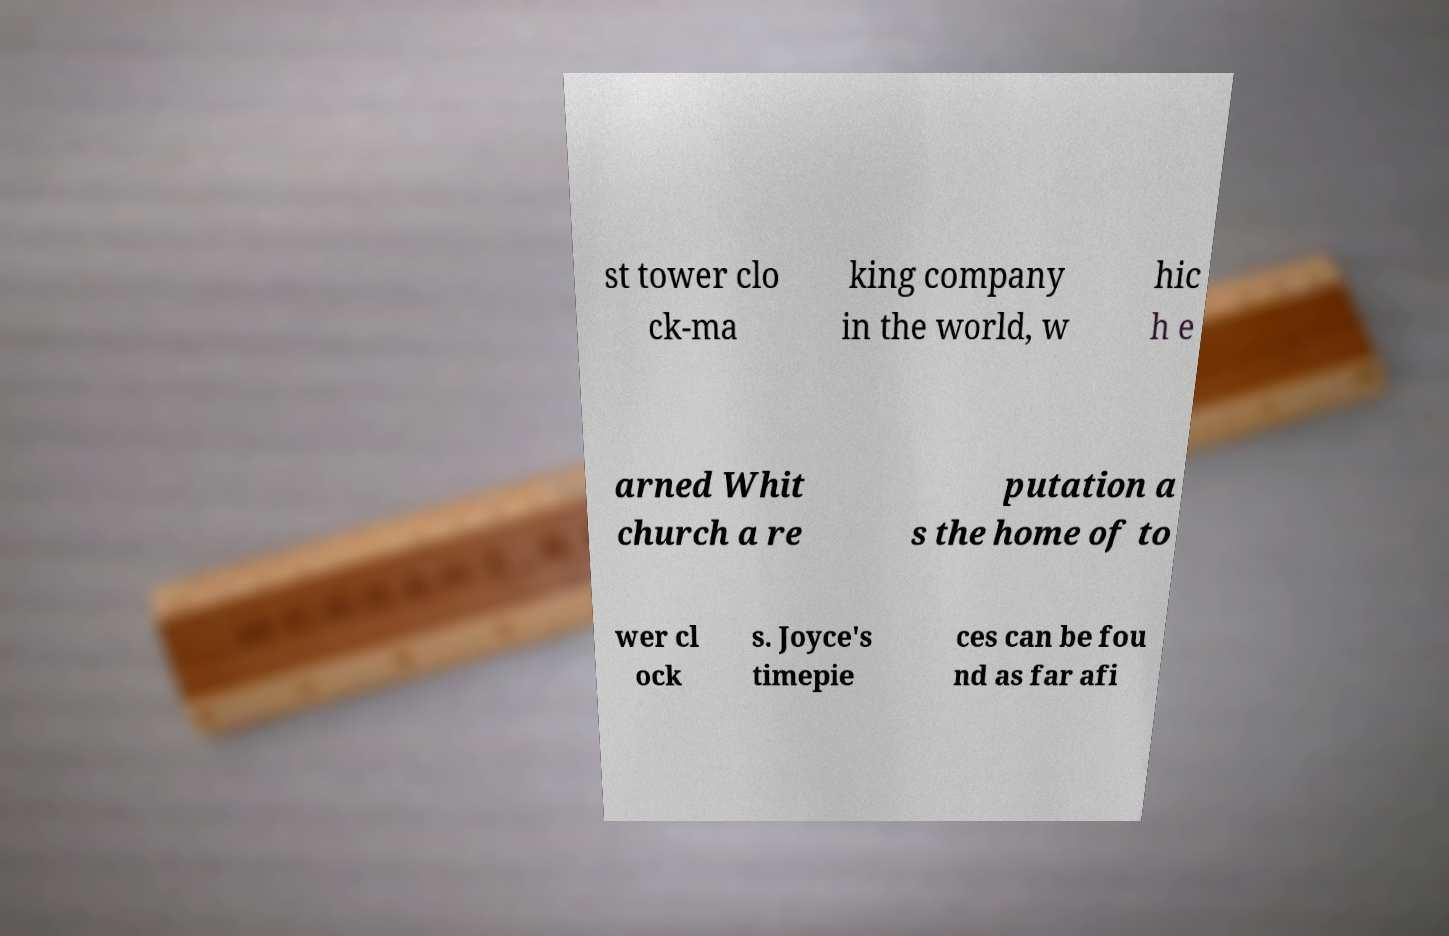What messages or text are displayed in this image? I need them in a readable, typed format. st tower clo ck-ma king company in the world, w hic h e arned Whit church a re putation a s the home of to wer cl ock s. Joyce's timepie ces can be fou nd as far afi 